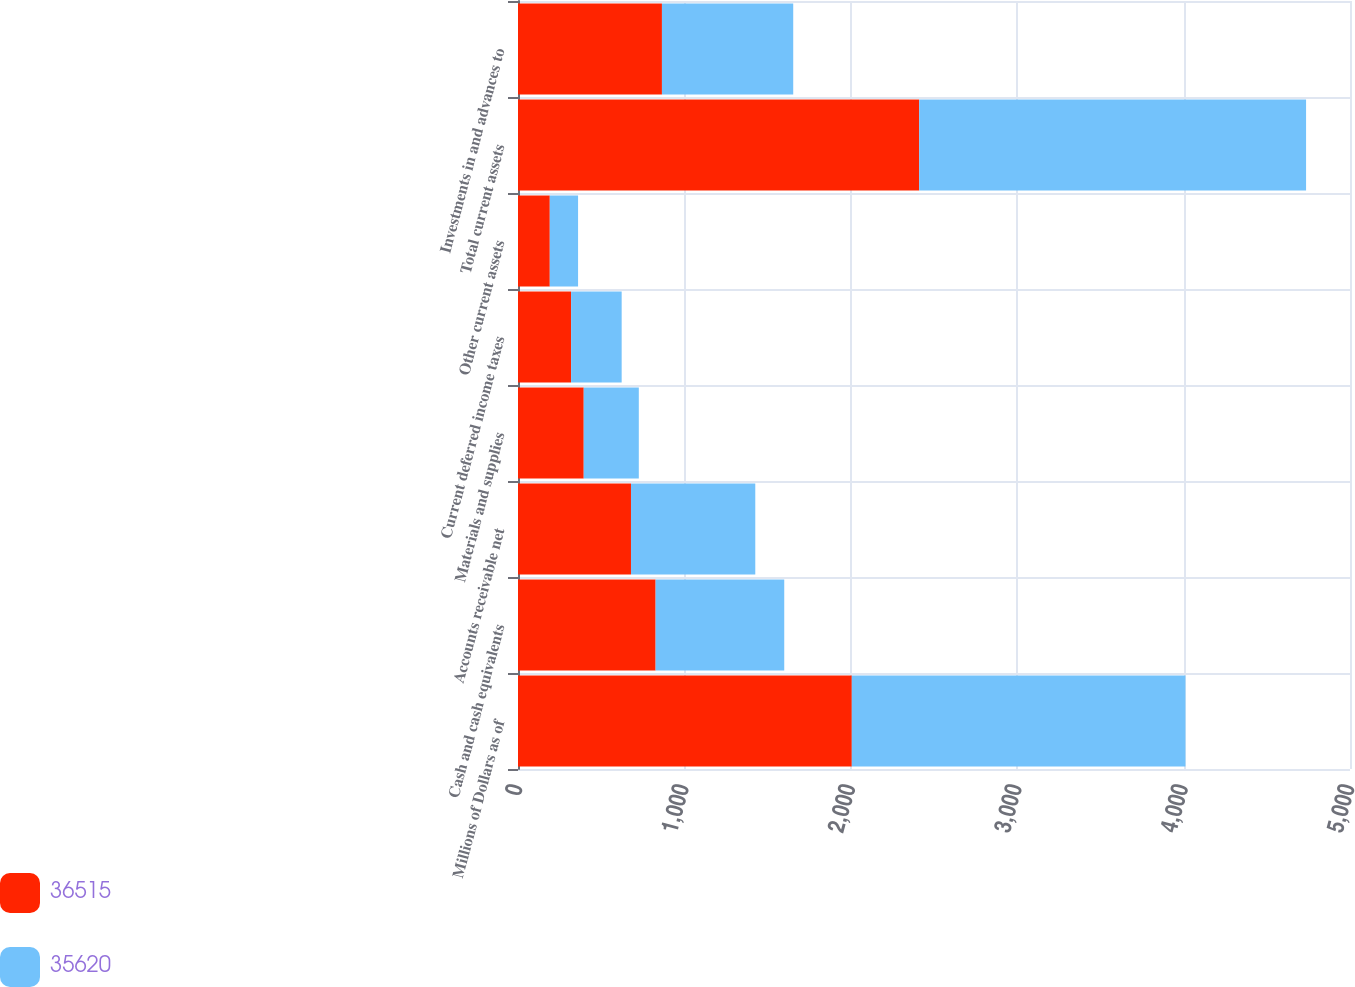Convert chart to OTSL. <chart><loc_0><loc_0><loc_500><loc_500><stacked_bar_chart><ecel><fcel>Millions of Dollars as of<fcel>Cash and cash equivalents<fcel>Accounts receivable net<fcel>Materials and supplies<fcel>Current deferred income taxes<fcel>Other current assets<fcel>Total current assets<fcel>Investments in and advances to<nl><fcel>36515<fcel>2006<fcel>827<fcel>679<fcel>395<fcel>319<fcel>191<fcel>2411<fcel>865<nl><fcel>35620<fcel>2005<fcel>773<fcel>747<fcel>331<fcel>304<fcel>170<fcel>2325<fcel>789<nl></chart> 